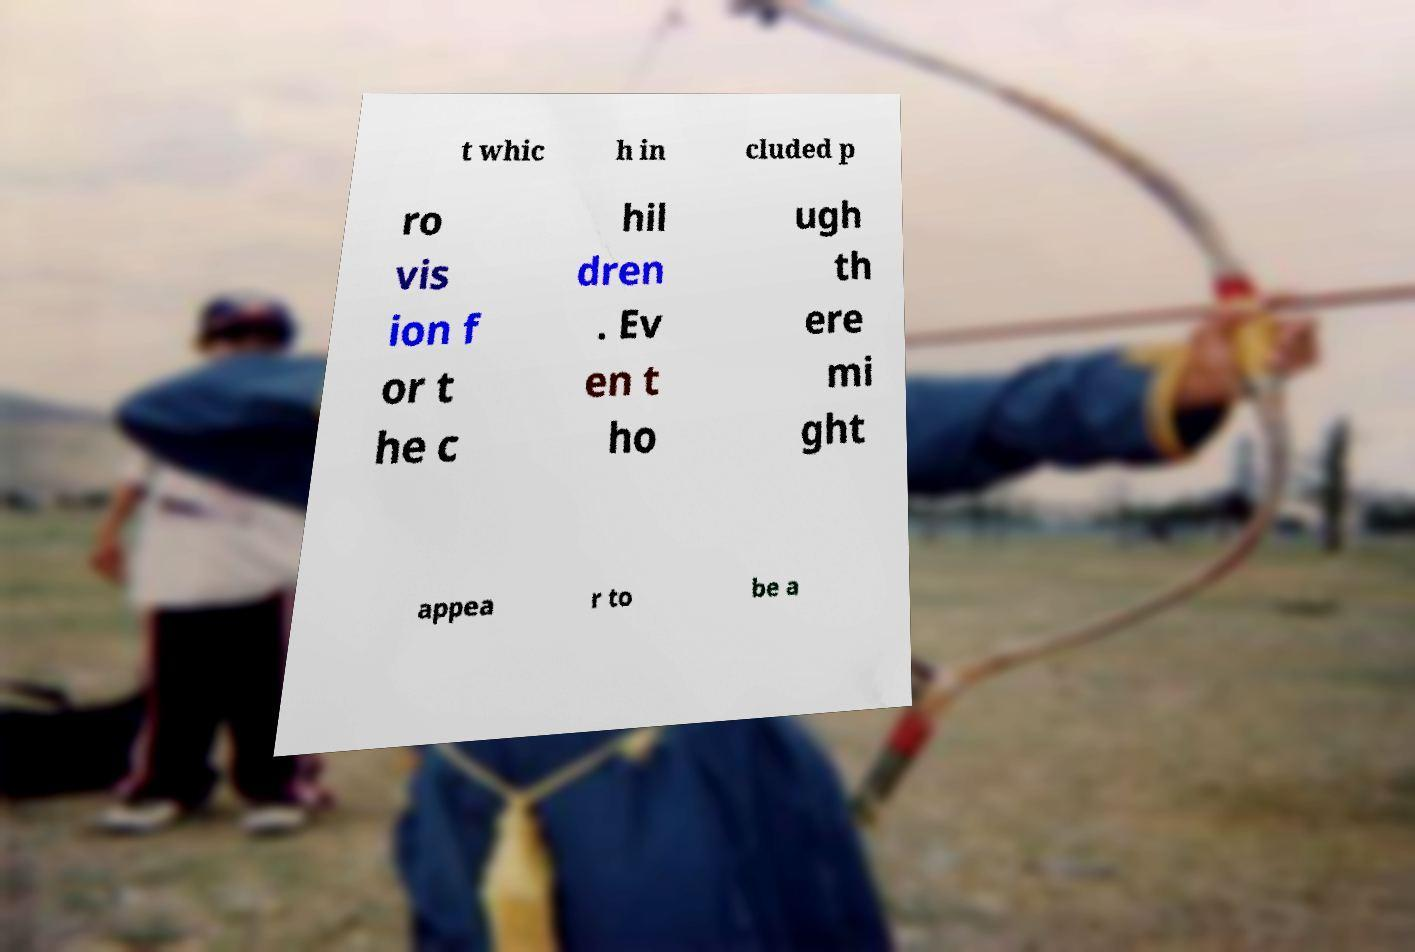Could you extract and type out the text from this image? t whic h in cluded p ro vis ion f or t he c hil dren . Ev en t ho ugh th ere mi ght appea r to be a 